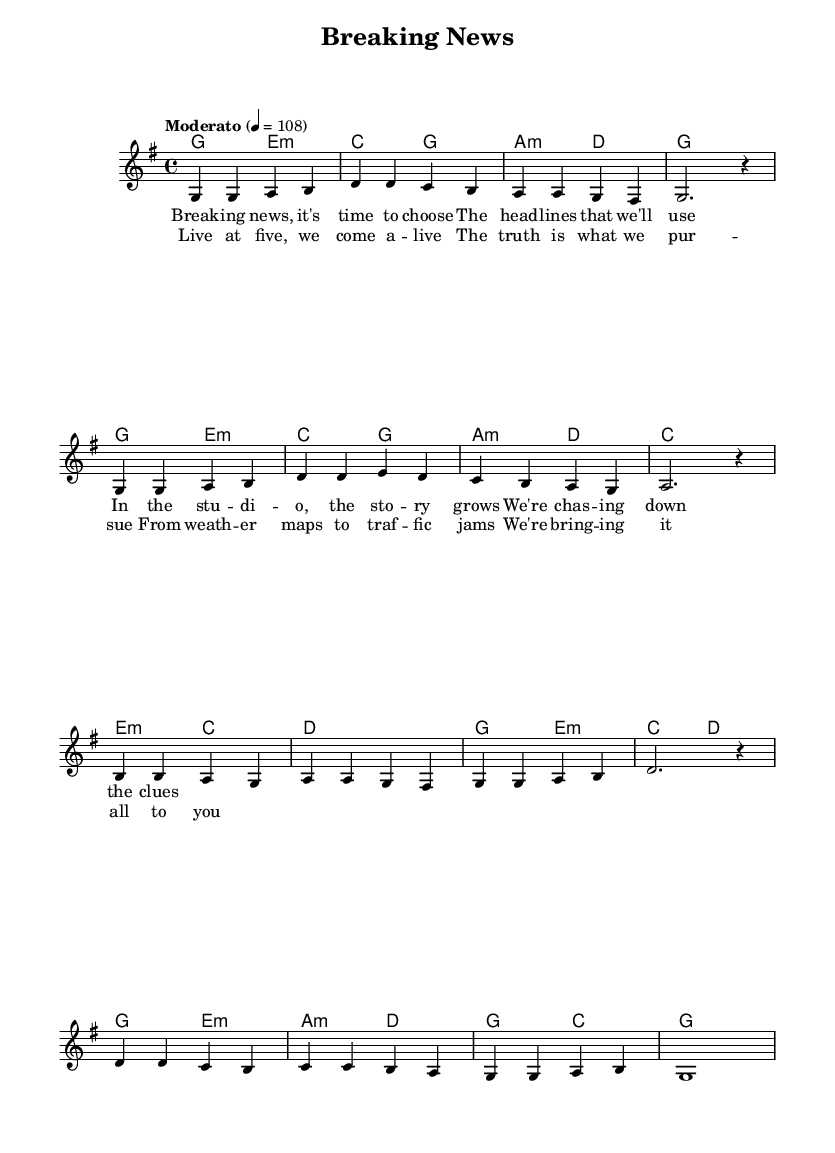What is the key signature of this music? The key signature is G major, which has one sharp (F#).
Answer: G major What is the time signature of this music? The time signature is 4/4, indicating four beats per measure.
Answer: 4/4 What is the tempo marking for this piece? The tempo is marked as Moderato, which generally indicates a moderate speed.
Answer: Moderato How many measures are in the verse? The verse contains 4 measures, as indicated by the grouping of the musical notation.
Answer: 4 What is the first lyric of the chorus? The first lyric of the chorus is "Live at five," which introduces the section.
Answer: Live at five Which chords are used in the first measure? The first measure uses the G major chord. We identify this by looking at the chord names written above the staff.
Answer: G major How does the harmony in the second measure compare to the first measure? The harmony in the second measure is E minor, which differs from the G major chord in the first measure as it has a different root note and is a minor chord.
Answer: E minor 